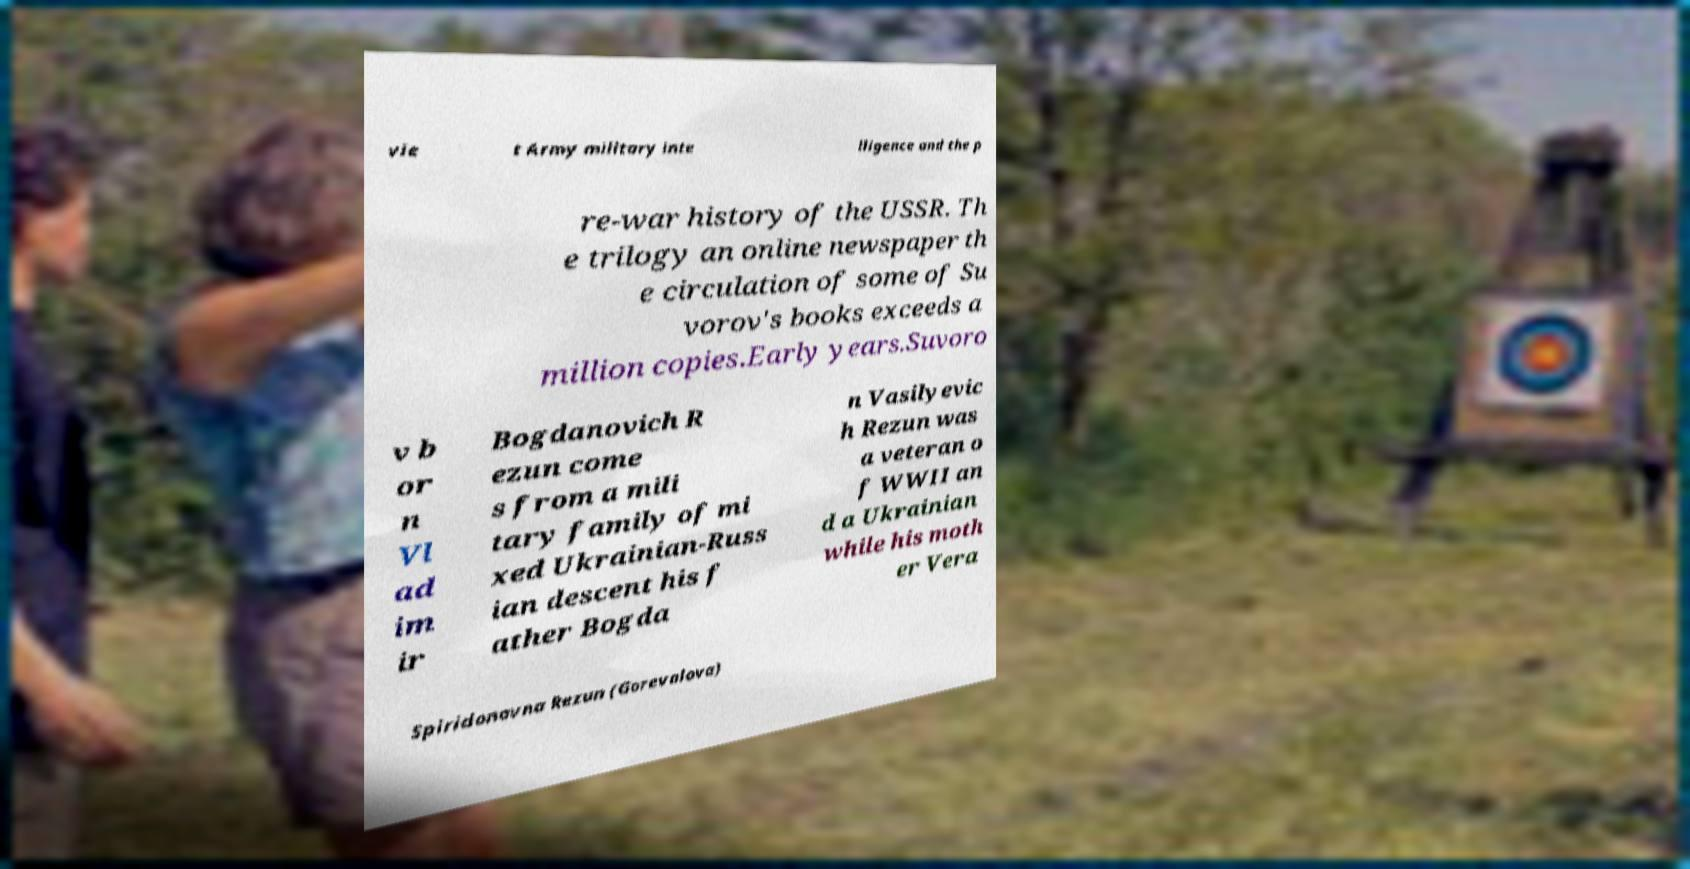Could you assist in decoding the text presented in this image and type it out clearly? vie t Army military inte lligence and the p re-war history of the USSR. Th e trilogy an online newspaper th e circulation of some of Su vorov's books exceeds a million copies.Early years.Suvoro v b or n Vl ad im ir Bogdanovich R ezun come s from a mili tary family of mi xed Ukrainian-Russ ian descent his f ather Bogda n Vasilyevic h Rezun was a veteran o f WWII an d a Ukrainian while his moth er Vera Spiridonovna Rezun (Gorevalova) 